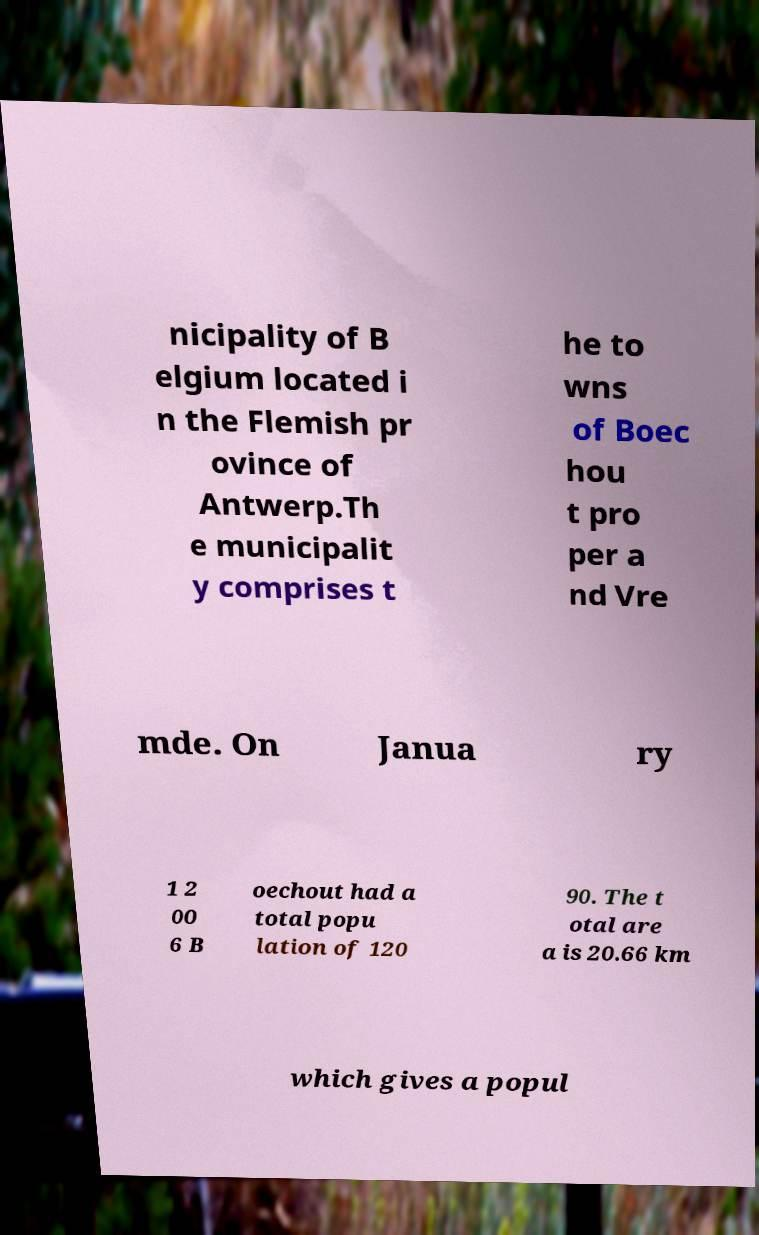I need the written content from this picture converted into text. Can you do that? nicipality of B elgium located i n the Flemish pr ovince of Antwerp.Th e municipalit y comprises t he to wns of Boec hou t pro per a nd Vre mde. On Janua ry 1 2 00 6 B oechout had a total popu lation of 120 90. The t otal are a is 20.66 km which gives a popul 